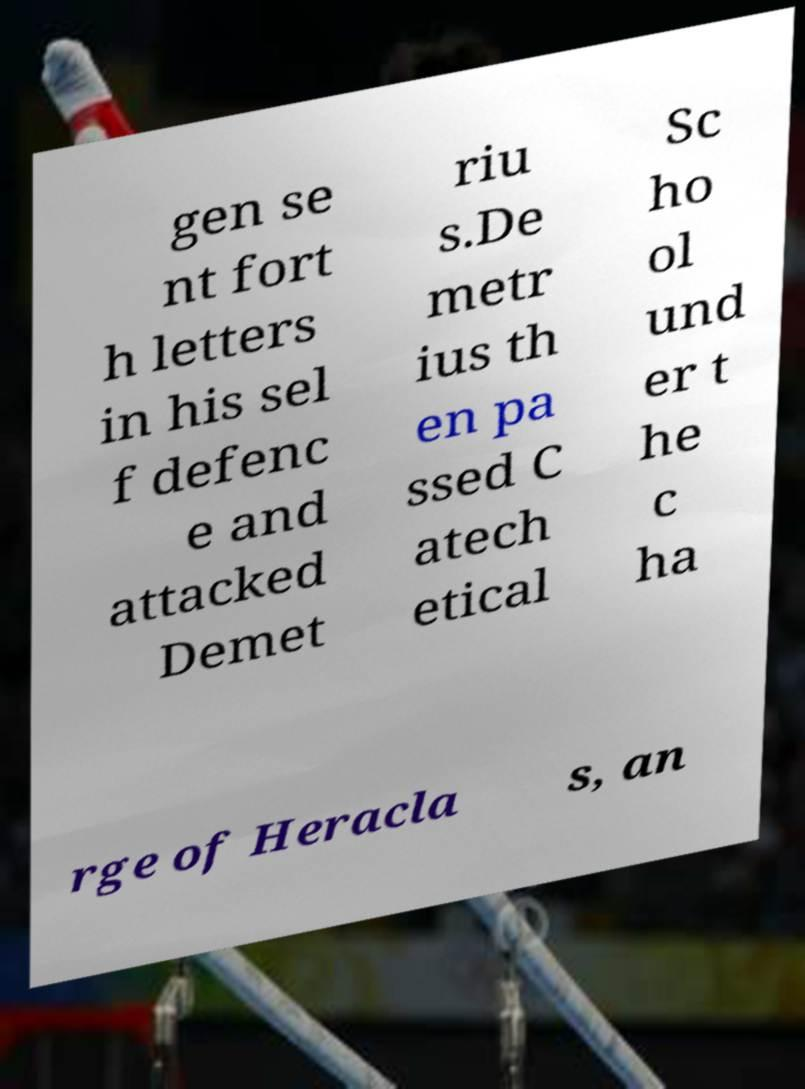For documentation purposes, I need the text within this image transcribed. Could you provide that? gen se nt fort h letters in his sel f defenc e and attacked Demet riu s.De metr ius th en pa ssed C atech etical Sc ho ol und er t he c ha rge of Heracla s, an 